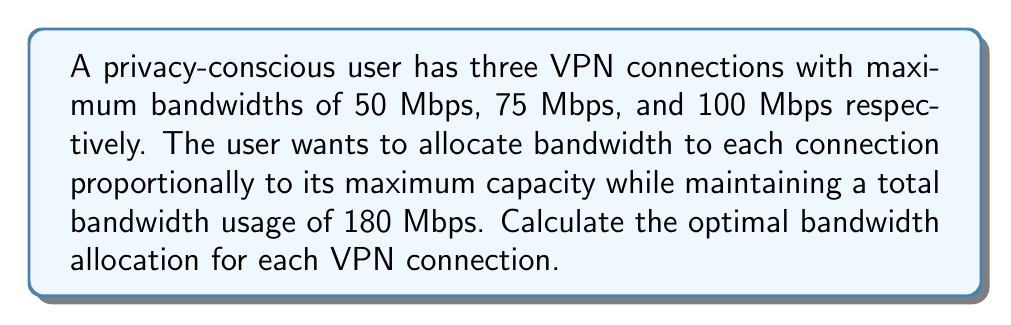What is the answer to this math problem? Let's solve this step-by-step:

1) Let $x$, $y$, and $z$ represent the bandwidth allocations for the 50 Mbps, 75 Mbps, and 100 Mbps connections respectively.

2) The total bandwidth usage should be 180 Mbps:
   $$x + y + z = 180$$

3) The allocations should be proportional to their maximum capacities:
   $$\frac{x}{50} = \frac{y}{75} = \frac{z}{100}$$

4) Let's call this common ratio $r$. Then:
   $$x = 50r, \quad y = 75r, \quad z = 100r$$

5) Substituting these into the total bandwidth equation:
   $$50r + 75r + 100r = 180$$
   $$225r = 180$$

6) Solving for $r$:
   $$r = \frac{180}{225} = 0.8$$

7) Now we can calculate the individual allocations:
   $$x = 50 * 0.8 = 40$$
   $$y = 75 * 0.8 = 60$$
   $$z = 100 * 0.8 = 80$$

8) Verify: $40 + 60 + 80 = 180$ Mbps (total bandwidth)
Answer: 40 Mbps, 60 Mbps, 80 Mbps 